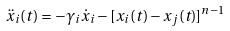<formula> <loc_0><loc_0><loc_500><loc_500>\ddot { x } _ { i } ( t ) = - \gamma _ { i } \dot { x } _ { i } - [ x _ { i } ( t ) - x _ { j } ( t ) ] ^ { n - 1 }</formula> 